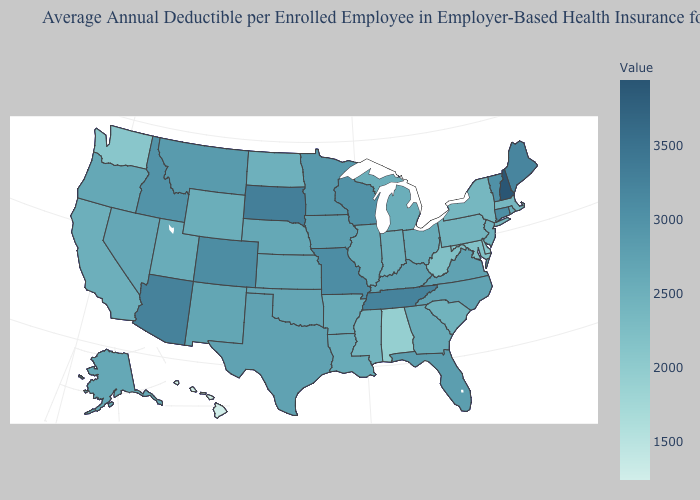Does New Hampshire have the highest value in the USA?
Give a very brief answer. Yes. Which states hav the highest value in the South?
Give a very brief answer. Tennessee. Does New Hampshire have the highest value in the USA?
Keep it brief. Yes. Which states have the highest value in the USA?
Write a very short answer. New Hampshire. 